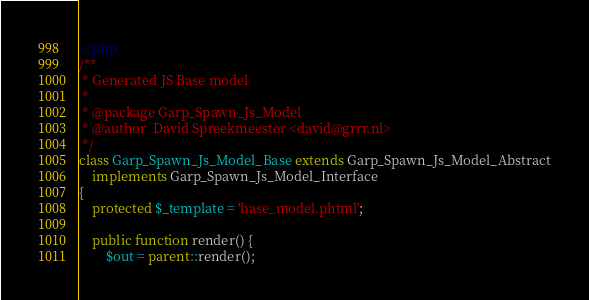<code> <loc_0><loc_0><loc_500><loc_500><_PHP_><?php
/**
 * Generated JS Base model
 *
 * @package Garp_Spawn_Js_Model
 * @author  David Spreekmeester <david@grrr.nl>
 */
class Garp_Spawn_Js_Model_Base extends Garp_Spawn_Js_Model_Abstract
    implements Garp_Spawn_Js_Model_Interface
{
    protected $_template = 'base_model.phtml';

    public function render() {
        $out = parent::render();</code> 